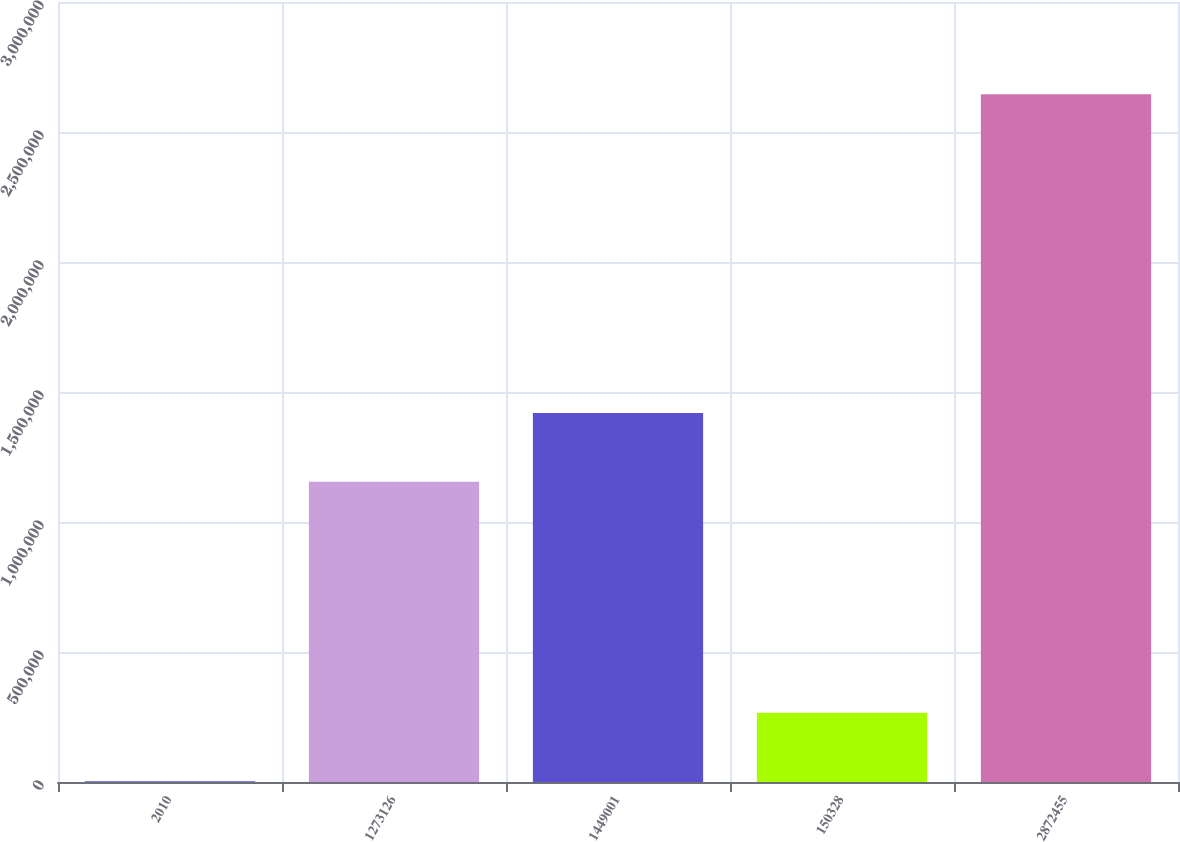Convert chart to OTSL. <chart><loc_0><loc_0><loc_500><loc_500><bar_chart><fcel>2010<fcel>1273126<fcel>1449001<fcel>150328<fcel>2872455<nl><fcel>2009<fcel>1.15449e+06<fcel>1.41877e+06<fcel>266286<fcel>2.64477e+06<nl></chart> 